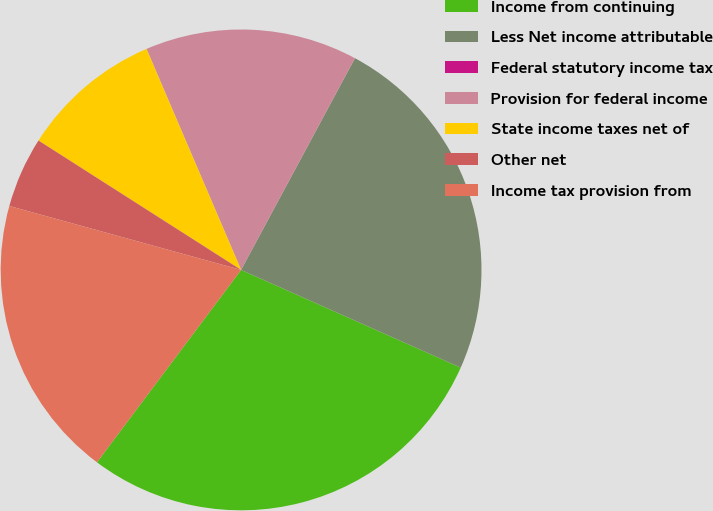<chart> <loc_0><loc_0><loc_500><loc_500><pie_chart><fcel>Income from continuing<fcel>Less Net income attributable<fcel>Federal statutory income tax<fcel>Provision for federal income<fcel>State income taxes net of<fcel>Other net<fcel>Income tax provision from<nl><fcel>28.57%<fcel>23.81%<fcel>0.0%<fcel>14.29%<fcel>9.52%<fcel>4.76%<fcel>19.05%<nl></chart> 